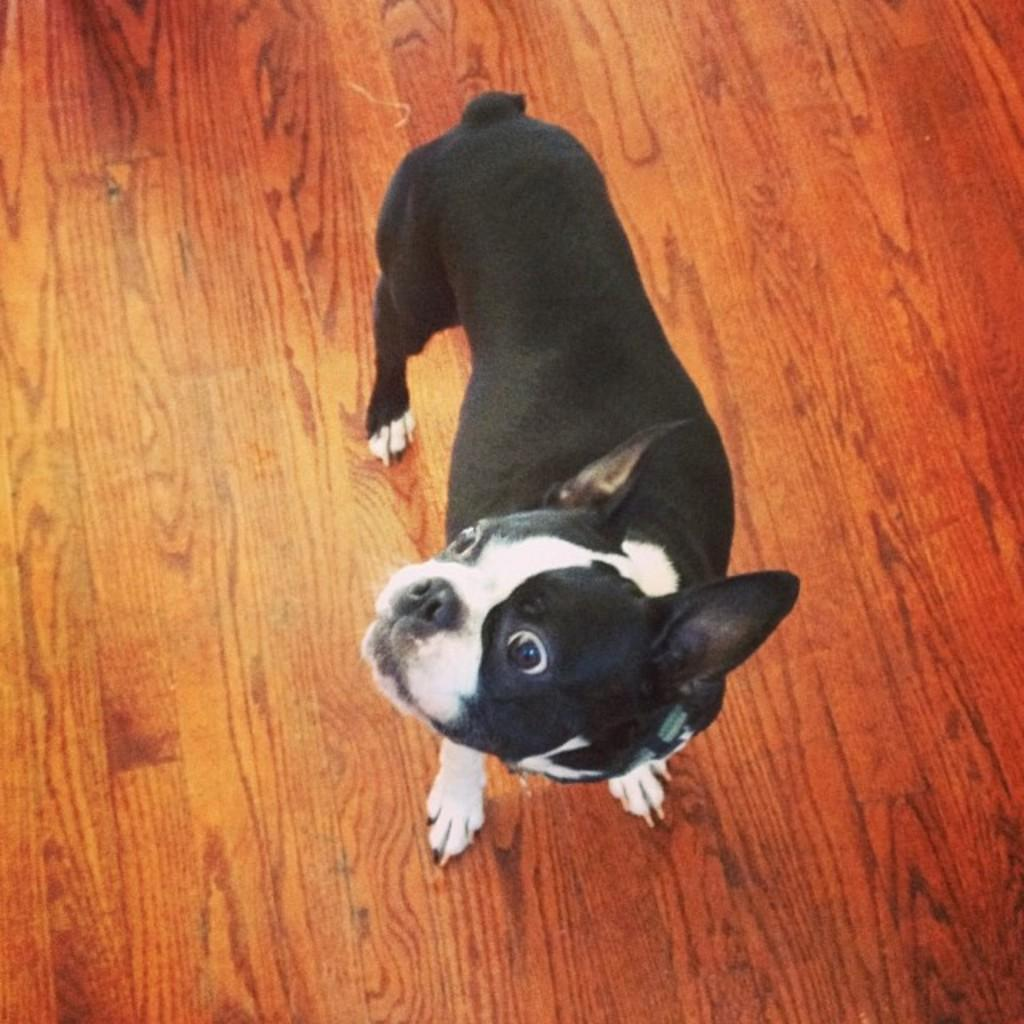What type of animal is in the image? There is a black dog in the image. What is the dog standing on? The dog is standing on the wooden floor. What type of lumber is the dog sorting in the image? There is no lumber or sorting activity present in the image; it features a black dog standing on a wooden floor. 